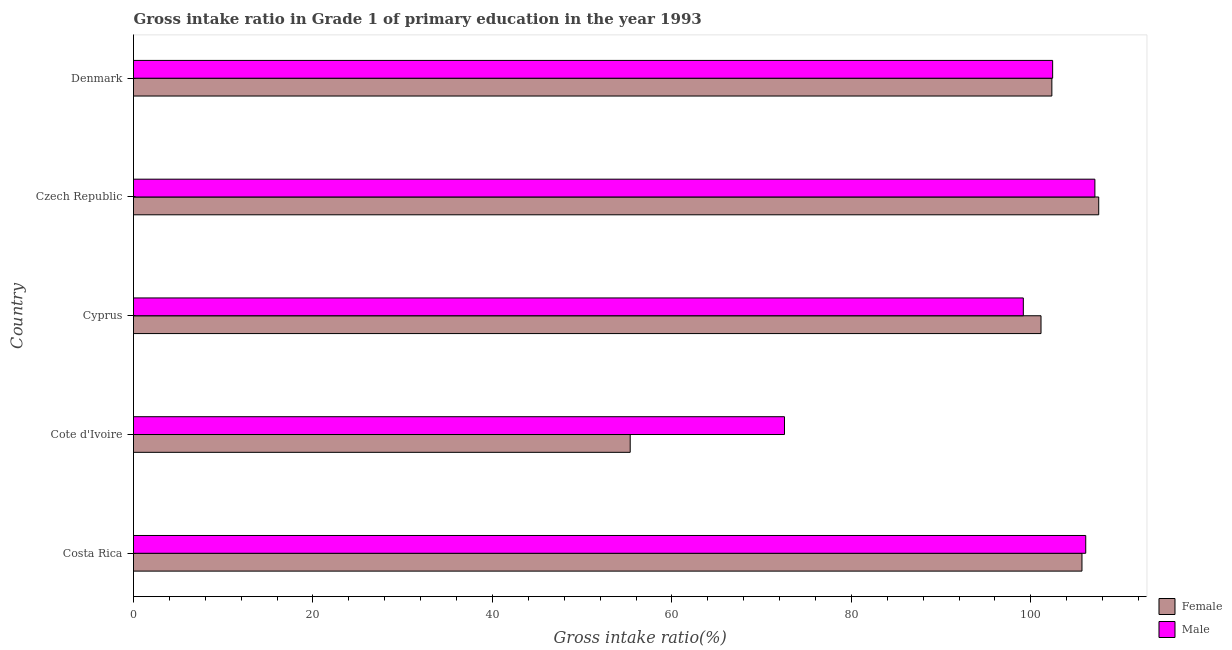How many different coloured bars are there?
Make the answer very short. 2. How many groups of bars are there?
Provide a short and direct response. 5. Are the number of bars on each tick of the Y-axis equal?
Ensure brevity in your answer.  Yes. How many bars are there on the 5th tick from the top?
Give a very brief answer. 2. How many bars are there on the 5th tick from the bottom?
Make the answer very short. 2. What is the label of the 2nd group of bars from the top?
Make the answer very short. Czech Republic. What is the gross intake ratio(female) in Cote d'Ivoire?
Your response must be concise. 55.35. Across all countries, what is the maximum gross intake ratio(male)?
Make the answer very short. 107.14. Across all countries, what is the minimum gross intake ratio(female)?
Offer a very short reply. 55.35. In which country was the gross intake ratio(male) maximum?
Provide a short and direct response. Czech Republic. In which country was the gross intake ratio(male) minimum?
Ensure brevity in your answer.  Cote d'Ivoire. What is the total gross intake ratio(female) in the graph?
Your answer should be very brief. 472.09. What is the difference between the gross intake ratio(female) in Costa Rica and that in Cyprus?
Your answer should be very brief. 4.56. What is the difference between the gross intake ratio(female) in Cote d'Ivoire and the gross intake ratio(male) in Cyprus?
Offer a very short reply. -43.81. What is the average gross intake ratio(female) per country?
Your answer should be compact. 94.42. What is the difference between the gross intake ratio(female) and gross intake ratio(male) in Cote d'Ivoire?
Ensure brevity in your answer.  -17.19. In how many countries, is the gross intake ratio(female) greater than 32 %?
Make the answer very short. 5. What is the ratio of the gross intake ratio(male) in Cote d'Ivoire to that in Cyprus?
Give a very brief answer. 0.73. Is the difference between the gross intake ratio(male) in Cyprus and Czech Republic greater than the difference between the gross intake ratio(female) in Cyprus and Czech Republic?
Provide a short and direct response. No. What is the difference between the highest and the second highest gross intake ratio(female)?
Provide a succinct answer. 1.87. What is the difference between the highest and the lowest gross intake ratio(male)?
Offer a terse response. 34.59. In how many countries, is the gross intake ratio(male) greater than the average gross intake ratio(male) taken over all countries?
Provide a succinct answer. 4. Is the sum of the gross intake ratio(female) in Costa Rica and Czech Republic greater than the maximum gross intake ratio(male) across all countries?
Offer a very short reply. Yes. What does the 1st bar from the bottom in Cyprus represents?
Give a very brief answer. Female. How many bars are there?
Ensure brevity in your answer.  10. Are all the bars in the graph horizontal?
Provide a short and direct response. Yes. How many countries are there in the graph?
Make the answer very short. 5. What is the difference between two consecutive major ticks on the X-axis?
Offer a terse response. 20. Are the values on the major ticks of X-axis written in scientific E-notation?
Keep it short and to the point. No. Does the graph contain grids?
Ensure brevity in your answer.  No. How are the legend labels stacked?
Keep it short and to the point. Vertical. What is the title of the graph?
Make the answer very short. Gross intake ratio in Grade 1 of primary education in the year 1993. What is the label or title of the X-axis?
Ensure brevity in your answer.  Gross intake ratio(%). What is the Gross intake ratio(%) of Female in Costa Rica?
Offer a very short reply. 105.7. What is the Gross intake ratio(%) of Male in Costa Rica?
Your answer should be compact. 106.12. What is the Gross intake ratio(%) in Female in Cote d'Ivoire?
Provide a short and direct response. 55.35. What is the Gross intake ratio(%) of Male in Cote d'Ivoire?
Give a very brief answer. 72.55. What is the Gross intake ratio(%) of Female in Cyprus?
Your answer should be very brief. 101.13. What is the Gross intake ratio(%) of Male in Cyprus?
Give a very brief answer. 99.16. What is the Gross intake ratio(%) in Female in Czech Republic?
Make the answer very short. 107.57. What is the Gross intake ratio(%) of Male in Czech Republic?
Ensure brevity in your answer.  107.14. What is the Gross intake ratio(%) in Female in Denmark?
Your answer should be very brief. 102.34. What is the Gross intake ratio(%) in Male in Denmark?
Make the answer very short. 102.43. Across all countries, what is the maximum Gross intake ratio(%) of Female?
Offer a very short reply. 107.57. Across all countries, what is the maximum Gross intake ratio(%) of Male?
Give a very brief answer. 107.14. Across all countries, what is the minimum Gross intake ratio(%) in Female?
Provide a succinct answer. 55.35. Across all countries, what is the minimum Gross intake ratio(%) in Male?
Offer a very short reply. 72.55. What is the total Gross intake ratio(%) in Female in the graph?
Ensure brevity in your answer.  472.09. What is the total Gross intake ratio(%) of Male in the graph?
Give a very brief answer. 487.4. What is the difference between the Gross intake ratio(%) in Female in Costa Rica and that in Cote d'Ivoire?
Your answer should be very brief. 50.35. What is the difference between the Gross intake ratio(%) in Male in Costa Rica and that in Cote d'Ivoire?
Make the answer very short. 33.57. What is the difference between the Gross intake ratio(%) in Female in Costa Rica and that in Cyprus?
Your response must be concise. 4.56. What is the difference between the Gross intake ratio(%) of Male in Costa Rica and that in Cyprus?
Offer a very short reply. 6.95. What is the difference between the Gross intake ratio(%) in Female in Costa Rica and that in Czech Republic?
Provide a succinct answer. -1.87. What is the difference between the Gross intake ratio(%) of Male in Costa Rica and that in Czech Republic?
Offer a very short reply. -1.02. What is the difference between the Gross intake ratio(%) in Female in Costa Rica and that in Denmark?
Provide a short and direct response. 3.35. What is the difference between the Gross intake ratio(%) of Male in Costa Rica and that in Denmark?
Your answer should be very brief. 3.69. What is the difference between the Gross intake ratio(%) of Female in Cote d'Ivoire and that in Cyprus?
Your response must be concise. -45.78. What is the difference between the Gross intake ratio(%) of Male in Cote d'Ivoire and that in Cyprus?
Your answer should be compact. -26.62. What is the difference between the Gross intake ratio(%) of Female in Cote d'Ivoire and that in Czech Republic?
Offer a very short reply. -52.21. What is the difference between the Gross intake ratio(%) of Male in Cote d'Ivoire and that in Czech Republic?
Give a very brief answer. -34.59. What is the difference between the Gross intake ratio(%) of Female in Cote d'Ivoire and that in Denmark?
Give a very brief answer. -46.99. What is the difference between the Gross intake ratio(%) in Male in Cote d'Ivoire and that in Denmark?
Keep it short and to the point. -29.88. What is the difference between the Gross intake ratio(%) in Female in Cyprus and that in Czech Republic?
Your answer should be very brief. -6.43. What is the difference between the Gross intake ratio(%) in Male in Cyprus and that in Czech Republic?
Your answer should be very brief. -7.98. What is the difference between the Gross intake ratio(%) in Female in Cyprus and that in Denmark?
Your answer should be very brief. -1.21. What is the difference between the Gross intake ratio(%) of Male in Cyprus and that in Denmark?
Provide a succinct answer. -3.27. What is the difference between the Gross intake ratio(%) in Female in Czech Republic and that in Denmark?
Your answer should be very brief. 5.22. What is the difference between the Gross intake ratio(%) in Male in Czech Republic and that in Denmark?
Offer a very short reply. 4.71. What is the difference between the Gross intake ratio(%) of Female in Costa Rica and the Gross intake ratio(%) of Male in Cote d'Ivoire?
Ensure brevity in your answer.  33.15. What is the difference between the Gross intake ratio(%) in Female in Costa Rica and the Gross intake ratio(%) in Male in Cyprus?
Make the answer very short. 6.53. What is the difference between the Gross intake ratio(%) of Female in Costa Rica and the Gross intake ratio(%) of Male in Czech Republic?
Offer a terse response. -1.44. What is the difference between the Gross intake ratio(%) in Female in Costa Rica and the Gross intake ratio(%) in Male in Denmark?
Keep it short and to the point. 3.27. What is the difference between the Gross intake ratio(%) of Female in Cote d'Ivoire and the Gross intake ratio(%) of Male in Cyprus?
Keep it short and to the point. -43.81. What is the difference between the Gross intake ratio(%) of Female in Cote d'Ivoire and the Gross intake ratio(%) of Male in Czech Republic?
Provide a short and direct response. -51.79. What is the difference between the Gross intake ratio(%) of Female in Cote d'Ivoire and the Gross intake ratio(%) of Male in Denmark?
Your answer should be compact. -47.08. What is the difference between the Gross intake ratio(%) of Female in Cyprus and the Gross intake ratio(%) of Male in Czech Republic?
Your response must be concise. -6.01. What is the difference between the Gross intake ratio(%) of Female in Cyprus and the Gross intake ratio(%) of Male in Denmark?
Your response must be concise. -1.3. What is the difference between the Gross intake ratio(%) of Female in Czech Republic and the Gross intake ratio(%) of Male in Denmark?
Your response must be concise. 5.14. What is the average Gross intake ratio(%) in Female per country?
Your response must be concise. 94.42. What is the average Gross intake ratio(%) in Male per country?
Offer a terse response. 97.48. What is the difference between the Gross intake ratio(%) of Female and Gross intake ratio(%) of Male in Costa Rica?
Provide a succinct answer. -0.42. What is the difference between the Gross intake ratio(%) of Female and Gross intake ratio(%) of Male in Cote d'Ivoire?
Ensure brevity in your answer.  -17.19. What is the difference between the Gross intake ratio(%) of Female and Gross intake ratio(%) of Male in Cyprus?
Provide a succinct answer. 1.97. What is the difference between the Gross intake ratio(%) of Female and Gross intake ratio(%) of Male in Czech Republic?
Give a very brief answer. 0.43. What is the difference between the Gross intake ratio(%) of Female and Gross intake ratio(%) of Male in Denmark?
Make the answer very short. -0.09. What is the ratio of the Gross intake ratio(%) in Female in Costa Rica to that in Cote d'Ivoire?
Provide a succinct answer. 1.91. What is the ratio of the Gross intake ratio(%) of Male in Costa Rica to that in Cote d'Ivoire?
Your answer should be compact. 1.46. What is the ratio of the Gross intake ratio(%) in Female in Costa Rica to that in Cyprus?
Make the answer very short. 1.05. What is the ratio of the Gross intake ratio(%) of Male in Costa Rica to that in Cyprus?
Make the answer very short. 1.07. What is the ratio of the Gross intake ratio(%) of Female in Costa Rica to that in Czech Republic?
Your answer should be compact. 0.98. What is the ratio of the Gross intake ratio(%) in Male in Costa Rica to that in Czech Republic?
Your response must be concise. 0.99. What is the ratio of the Gross intake ratio(%) of Female in Costa Rica to that in Denmark?
Offer a terse response. 1.03. What is the ratio of the Gross intake ratio(%) of Male in Costa Rica to that in Denmark?
Your answer should be compact. 1.04. What is the ratio of the Gross intake ratio(%) in Female in Cote d'Ivoire to that in Cyprus?
Give a very brief answer. 0.55. What is the ratio of the Gross intake ratio(%) in Male in Cote d'Ivoire to that in Cyprus?
Keep it short and to the point. 0.73. What is the ratio of the Gross intake ratio(%) of Female in Cote d'Ivoire to that in Czech Republic?
Give a very brief answer. 0.51. What is the ratio of the Gross intake ratio(%) in Male in Cote d'Ivoire to that in Czech Republic?
Your response must be concise. 0.68. What is the ratio of the Gross intake ratio(%) of Female in Cote d'Ivoire to that in Denmark?
Provide a succinct answer. 0.54. What is the ratio of the Gross intake ratio(%) of Male in Cote d'Ivoire to that in Denmark?
Keep it short and to the point. 0.71. What is the ratio of the Gross intake ratio(%) in Female in Cyprus to that in Czech Republic?
Offer a very short reply. 0.94. What is the ratio of the Gross intake ratio(%) in Male in Cyprus to that in Czech Republic?
Your answer should be compact. 0.93. What is the ratio of the Gross intake ratio(%) in Female in Cyprus to that in Denmark?
Offer a terse response. 0.99. What is the ratio of the Gross intake ratio(%) in Male in Cyprus to that in Denmark?
Your answer should be compact. 0.97. What is the ratio of the Gross intake ratio(%) in Female in Czech Republic to that in Denmark?
Your answer should be compact. 1.05. What is the ratio of the Gross intake ratio(%) in Male in Czech Republic to that in Denmark?
Your answer should be very brief. 1.05. What is the difference between the highest and the second highest Gross intake ratio(%) of Female?
Ensure brevity in your answer.  1.87. What is the difference between the highest and the second highest Gross intake ratio(%) in Male?
Provide a succinct answer. 1.02. What is the difference between the highest and the lowest Gross intake ratio(%) of Female?
Offer a very short reply. 52.21. What is the difference between the highest and the lowest Gross intake ratio(%) in Male?
Your answer should be compact. 34.59. 